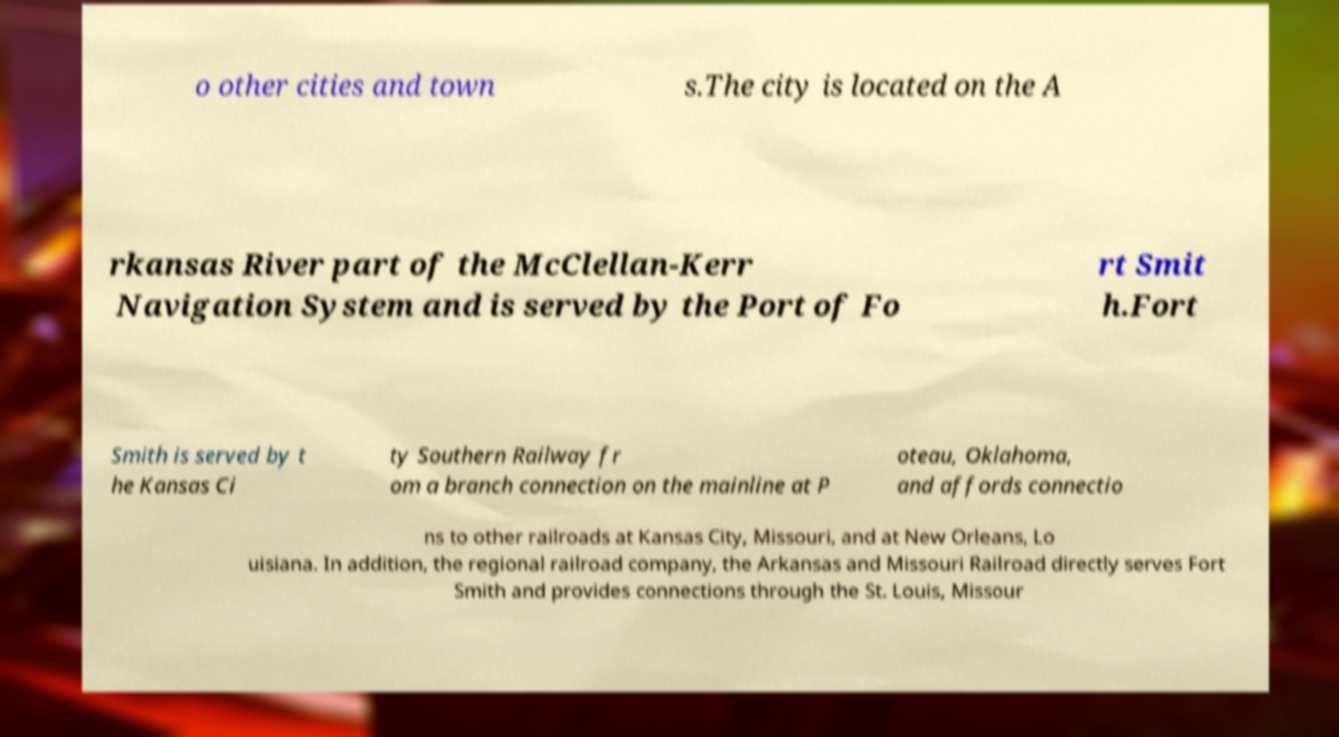I need the written content from this picture converted into text. Can you do that? o other cities and town s.The city is located on the A rkansas River part of the McClellan-Kerr Navigation System and is served by the Port of Fo rt Smit h.Fort Smith is served by t he Kansas Ci ty Southern Railway fr om a branch connection on the mainline at P oteau, Oklahoma, and affords connectio ns to other railroads at Kansas City, Missouri, and at New Orleans, Lo uisiana. In addition, the regional railroad company, the Arkansas and Missouri Railroad directly serves Fort Smith and provides connections through the St. Louis, Missour 